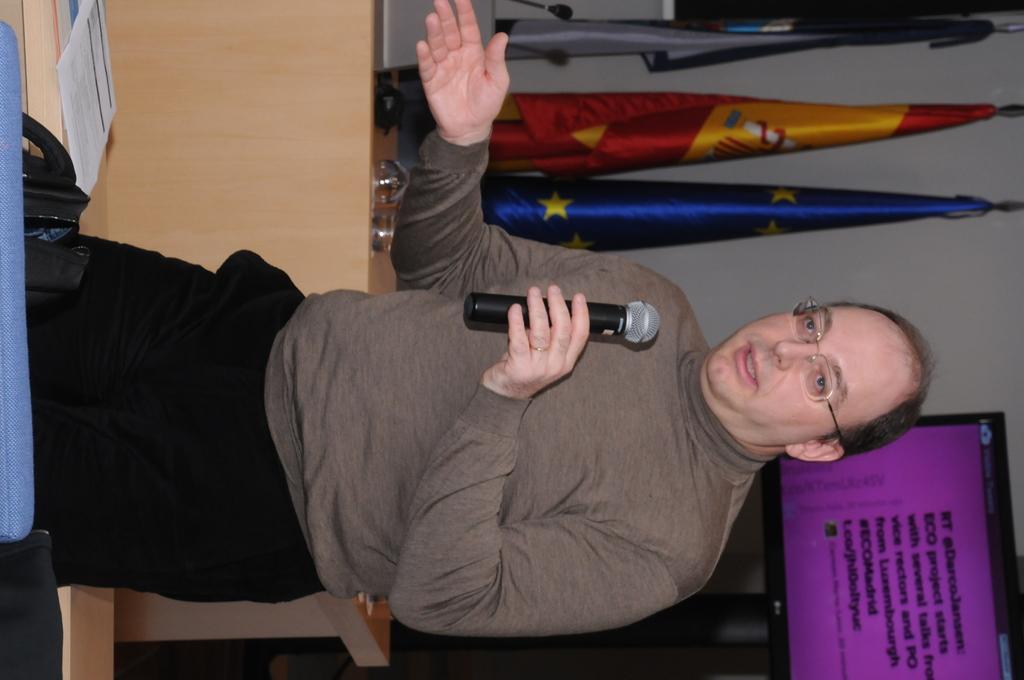How would you summarize this image in a sentence or two? In the center of the image a man is standing and holding a mic in his hand. In the background of the image we can see flags, wall are there. In the middle of the image there is a table. On the table some objects are there. At the bottom right corner screen is present. On the left side of the image we can see paper, bag are there. 